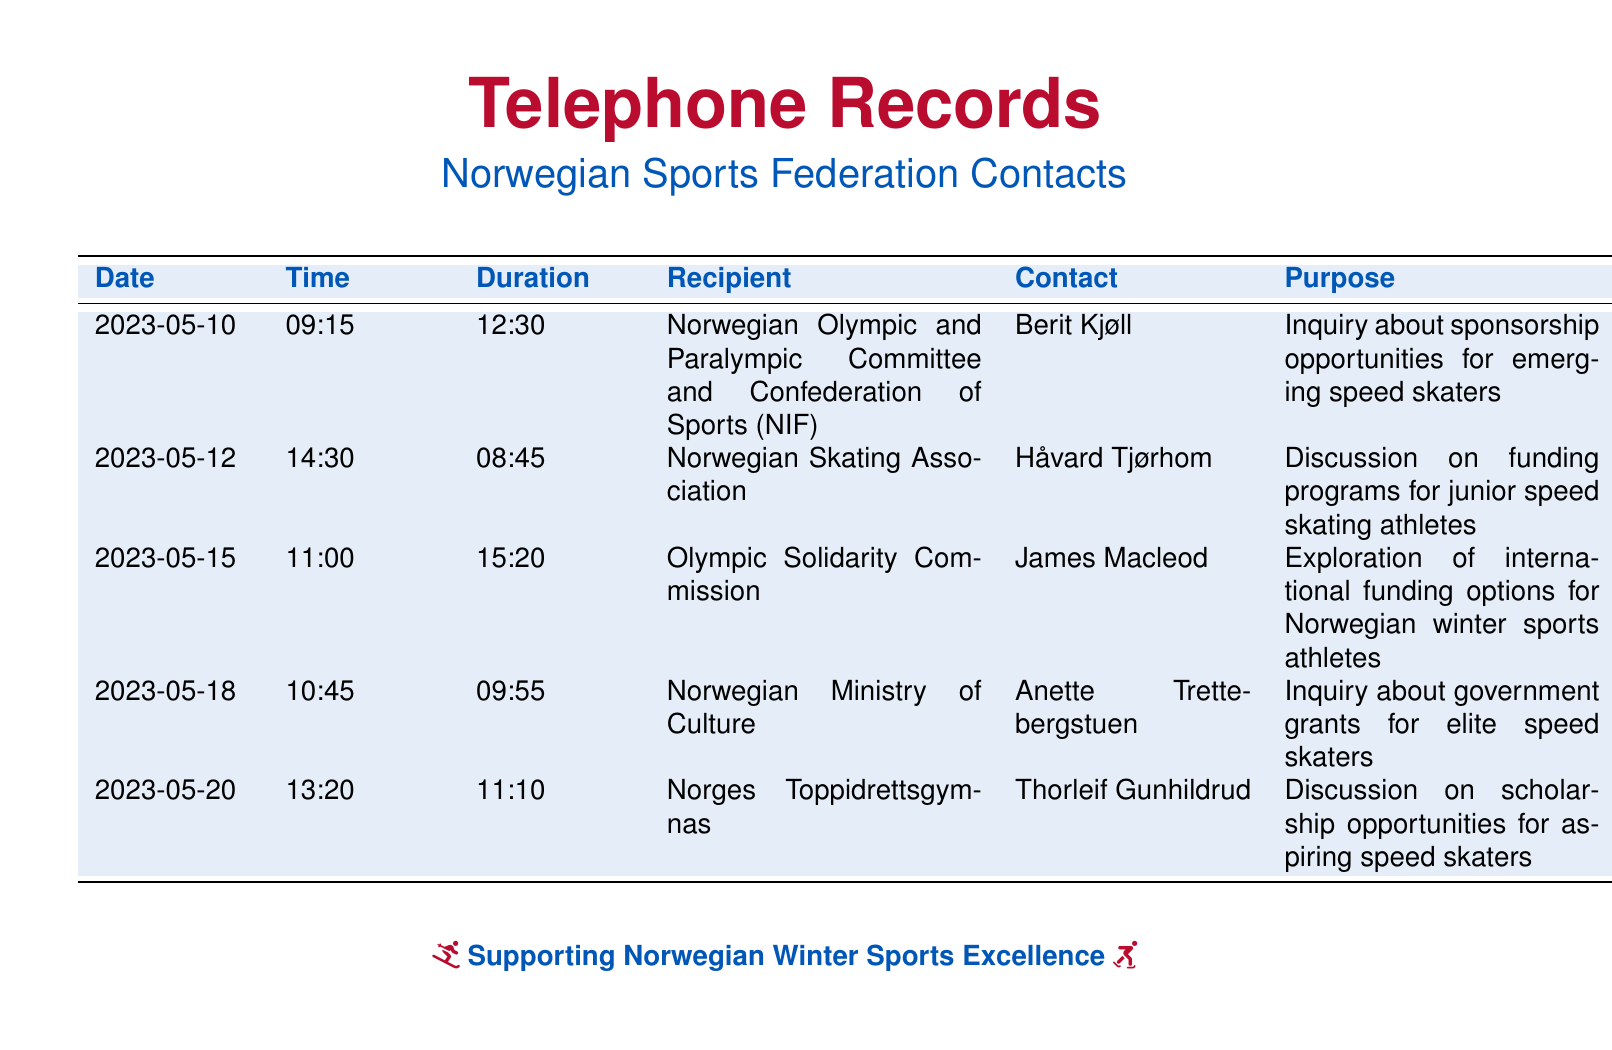What is the first date listed in the records? The first entry in the records shows a call made on May 10, 2023.
Answer: 2023-05-10 Who was contacted on May 12, 2023? The records show that Håvard Tjørhom from the Norwegian Skating Association was contacted.
Answer: Håvard Tjørhom What is the duration of the call on May 15, 2023? The call made on May 15, 2023, lasted for 15 minutes and 20 seconds.
Answer: 15:20 What was the purpose of the call to the Norwegian Ministry of Culture? The inquiry was related to government grants for elite speed skaters.
Answer: Inquiry about government grants Which organization was contacted about scholarship opportunities? Norges Toppidrettsgymnas was contacted regarding scholarship opportunities.
Answer: Norges Toppidrettsgymnas How many calls were made regarding sponsorship inquiries? There are two calls listed that pertain to sponsorship inquiries.
Answer: 2 What time was the call made on May 20, 2023? The call on May 20, 2023, was made at 13:20.
Answer: 13:20 Who is the recipient of the call regarding international funding options? The recipient of this call was James Macleod from the Olympic Solidarity Commission.
Answer: James Macleod 